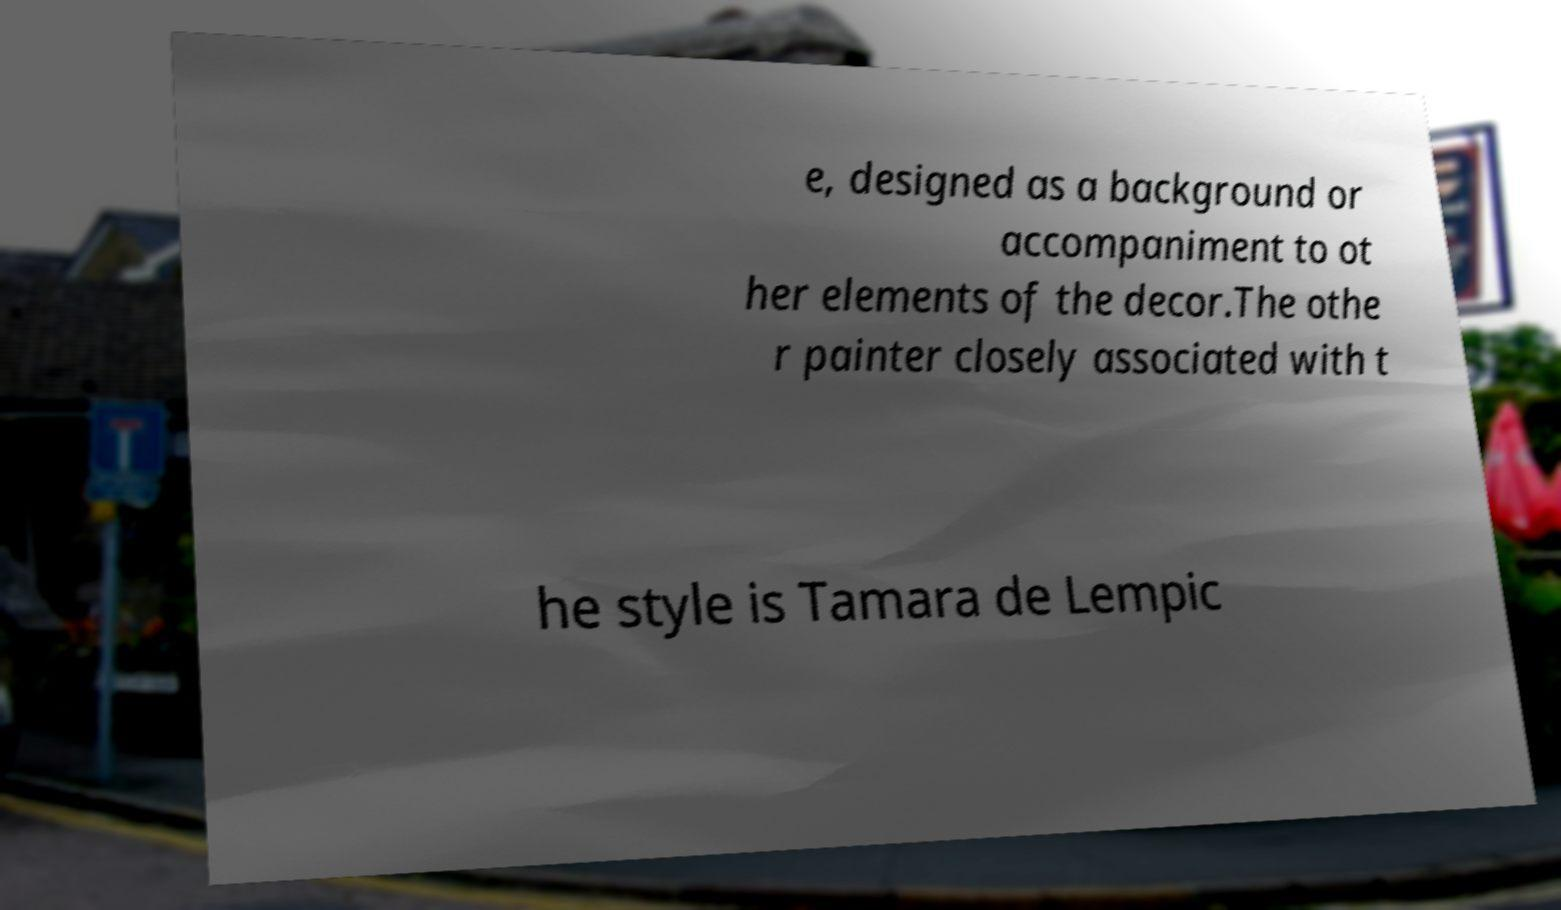Please read and relay the text visible in this image. What does it say? e, designed as a background or accompaniment to ot her elements of the decor.The othe r painter closely associated with t he style is Tamara de Lempic 